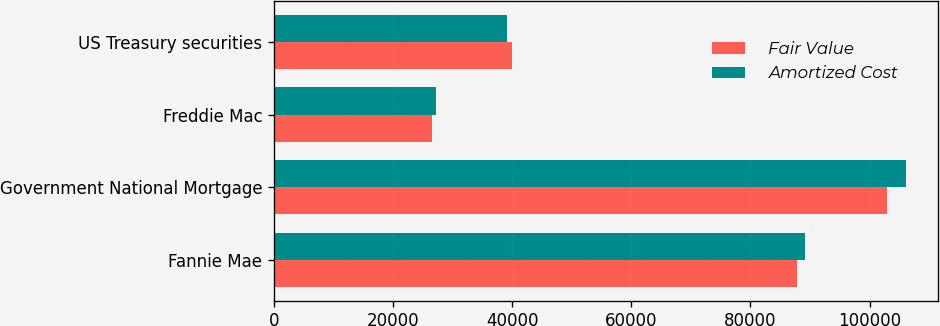Convert chart to OTSL. <chart><loc_0><loc_0><loc_500><loc_500><stacked_bar_chart><ecel><fcel>Fannie Mae<fcel>Government National Mortgage<fcel>Freddie Mac<fcel>US Treasury securities<nl><fcel>Fair Value<fcel>87898<fcel>102960<fcel>26617<fcel>39946<nl><fcel>Amortized Cost<fcel>89243<fcel>106200<fcel>27129<fcel>39164<nl></chart> 